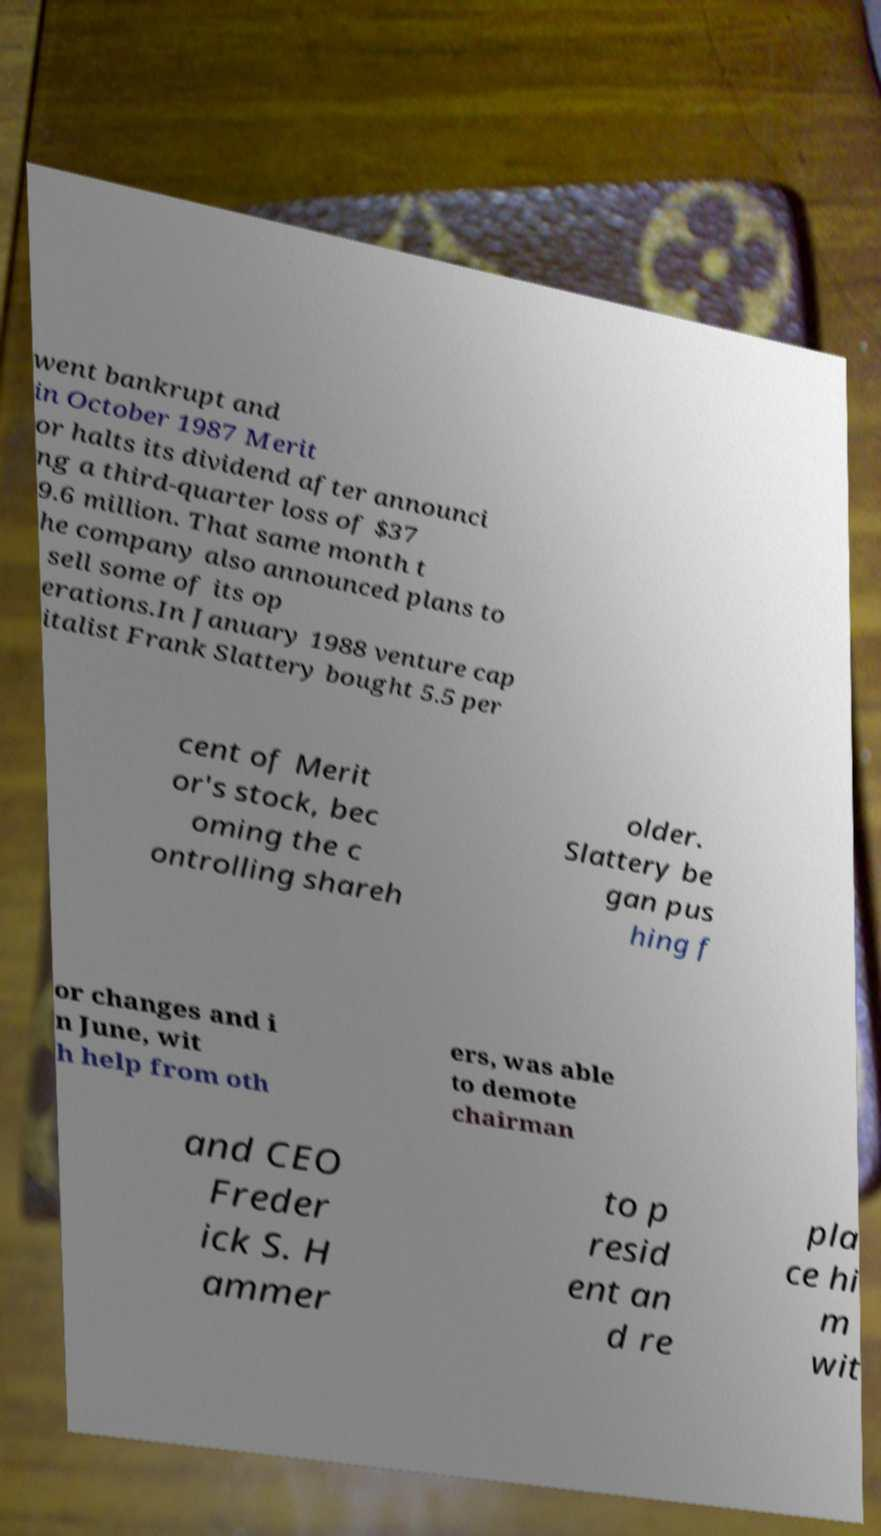Could you assist in decoding the text presented in this image and type it out clearly? went bankrupt and in October 1987 Merit or halts its dividend after announci ng a third-quarter loss of $37 9.6 million. That same month t he company also announced plans to sell some of its op erations.In January 1988 venture cap italist Frank Slattery bought 5.5 per cent of Merit or's stock, bec oming the c ontrolling shareh older. Slattery be gan pus hing f or changes and i n June, wit h help from oth ers, was able to demote chairman and CEO Freder ick S. H ammer to p resid ent an d re pla ce hi m wit 